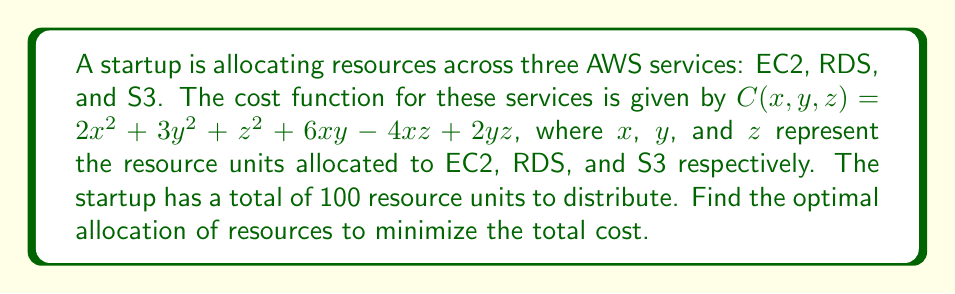What is the answer to this math problem? To solve this optimization problem, we'll use the method of Lagrange multipliers:

1) First, we set up the Lagrangian function:
   $$L(x, y, z, \lambda) = 2x^2 + 3y^2 + z^2 + 6xy - 4xz + 2yz + \lambda(x + y + z - 100)$$

2) Now, we take partial derivatives and set them equal to zero:
   $$\frac{\partial L}{\partial x} = 4x + 6y - 4z + \lambda = 0$$
   $$\frac{\partial L}{\partial y} = 6x + 6y + 2z + \lambda = 0$$
   $$\frac{\partial L}{\partial z} = -4x + 2y + 2z + \lambda = 0$$
   $$\frac{\partial L}{\partial \lambda} = x + y + z - 100 = 0$$

3) From the first three equations:
   $$4x + 6y - 4z = -\lambda$$
   $$6x + 6y + 2z = -\lambda$$
   $$-4x + 2y + 2z = -\lambda$$

4) Subtracting the third equation from the first:
   $$8x + 4y - 6z = 0$$
   $$4x + 2y - 3z = 0 \quad (1)$$

5) Subtracting the third equation from the second:
   $$10x + 4y = 0$$
   $$5x + 2y = 0 \quad (2)$$

6) From (2): $y = -\frac{5}{2}x$

7) Substituting this into (1):
   $$4x + 2(-\frac{5}{2}x) - 3z = 0$$
   $$4x - 5x - 3z = 0$$
   $$-x = 3z$$
   $$x = -3z$$

8) Substituting these into the constraint equation:
   $$-3z + (-\frac{5}{2})(-3z) + z = 100$$
   $$-3z + \frac{15}{2}z + z = 100$$
   $$\frac{11}{2}z = 100$$
   $$z = \frac{200}{11}$$

9) Therefore:
   $$x = -3z = -\frac{600}{11}$$
   $$y = -\frac{5}{2}x = \frac{1500}{22}$$

10) Rounding to the nearest whole number (as we're dealing with resource units):
    $x \approx 55$, $y \approx 68$, $z \approx 18$
Answer: EC2: 55 units, RDS: 68 units, S3: 18 units 